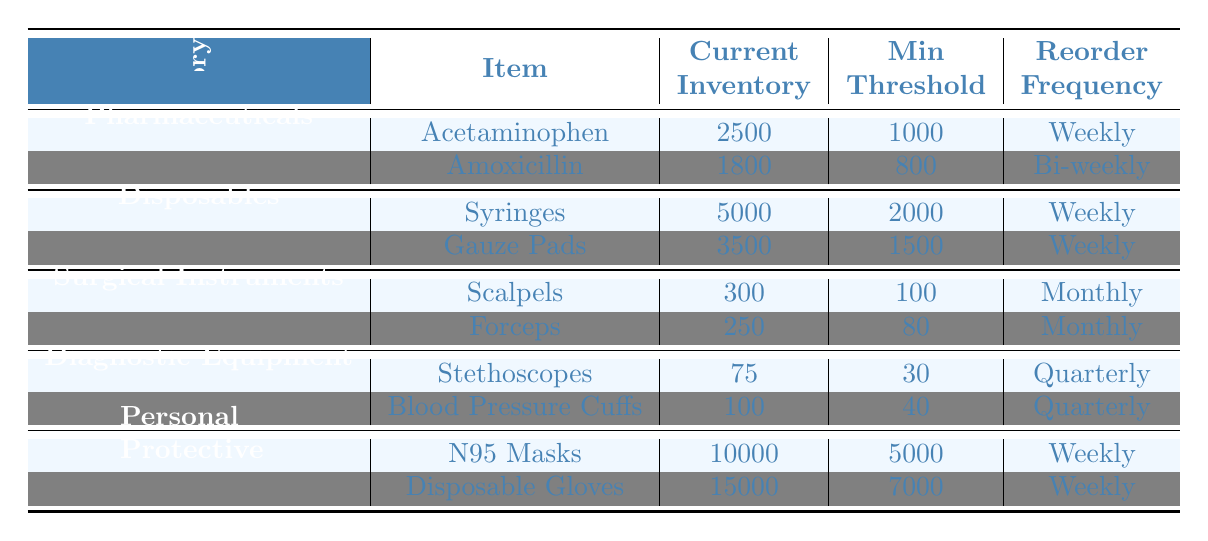What is the current inventory level of Acetaminophen? According to the table under the Pharmaceuticals category, the current inventory level for Acetaminophen is listed as 2500.
Answer: 2500 How often do we need to reorder Surgical Instruments? The reorder frequency for Surgical Instruments, which includes Scalpels and Forceps, is stated as Monthly in the table.
Answer: Monthly What is the minimum threshold for Disposable Gloves? In the table, under the Personal Protective Equipment category, the minimum threshold for Disposable Gloves is shown to be 7000.
Answer: 7000 Are there more N95 Masks or Disposable Gloves in current inventory? The current inventory for N95 Masks is 10000 and for Disposable Gloves is 15000. Since 15000 is greater than 10000, there are more Disposable Gloves.
Answer: Yes, there are more Disposable Gloves What is the average current inventory for the Personal Protective Equipment category? The current inventory for Personal Protective Equipment includes N95 Masks (10000) and Disposable Gloves (15000), so the average is (10000 + 15000) / 2 = 12500.
Answer: 12500 Is the current inventory for Scalpels above or below its minimum threshold? The current inventory for Scalpels is 300, and its minimum threshold is 100. Since 300 is greater than 100, it is above the minimum threshold.
Answer: Above What is the total minimum threshold for all Diagnostic Equipment? The minimum thresholds for Diagnostic Equipment are Stethoscopes (30) and Blood Pressure Cuffs (40). So, the total minimum threshold is 30 + 40 = 70.
Answer: 70 How often do we reorder Acetaminophen and Syringes? The reorder frequency for Acetaminophen is weekly, and for Syringes, it is also weekly. Both items have the same reorder frequency.
Answer: Weekly What item has the highest current inventory? By comparing the current inventories in the table, Disposable Gloves have the highest inventory level at 15000.
Answer: Disposable Gloves What is the difference in current inventory between Amoxicillin and Scalpels? The current inventory for Amoxicillin is 1800, and for Scalpels, it is 300. The difference is 1800 - 300 = 1500.
Answer: 1500 